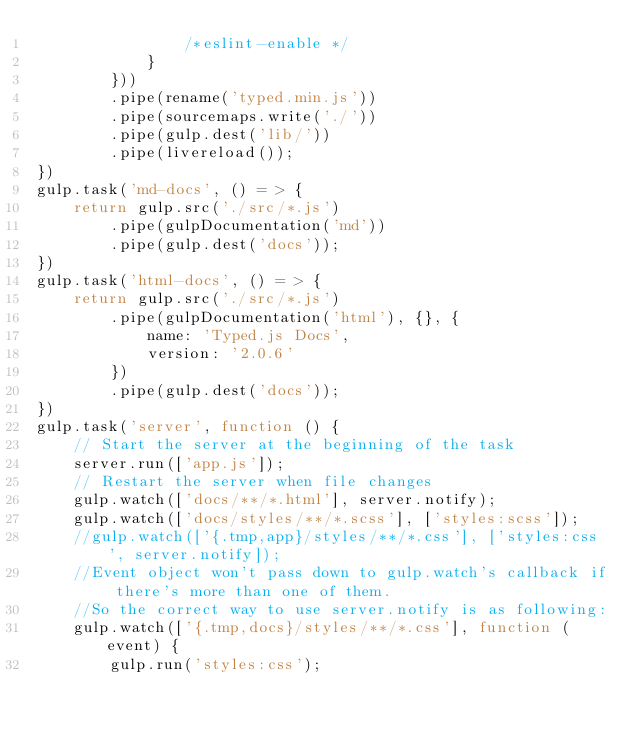Convert code to text. <code><loc_0><loc_0><loc_500><loc_500><_JavaScript_>                /*eslint-enable */
            }
        }))
        .pipe(rename('typed.min.js'))
        .pipe(sourcemaps.write('./'))
        .pipe(gulp.dest('lib/'))
        .pipe(livereload());
})
gulp.task('md-docs', () = > {
    return gulp.src('./src/*.js')
        .pipe(gulpDocumentation('md'))
        .pipe(gulp.dest('docs'));
})
gulp.task('html-docs', () = > {
    return gulp.src('./src/*.js')
        .pipe(gulpDocumentation('html'), {}, {
            name: 'Typed.js Docs',
            version: '2.0.6'
        })
        .pipe(gulp.dest('docs'));
})
gulp.task('server', function () {
    // Start the server at the beginning of the task
    server.run(['app.js']);
    // Restart the server when file changes
    gulp.watch(['docs/**/*.html'], server.notify);
    gulp.watch(['docs/styles/**/*.scss'], ['styles:scss']);
    //gulp.watch(['{.tmp,app}/styles/**/*.css'], ['styles:css', server.notify]);
    //Event object won't pass down to gulp.watch's callback if there's more than one of them.
    //So the correct way to use server.notify is as following:
    gulp.watch(['{.tmp,docs}/styles/**/*.css'], function (event) {
        gulp.run('styles:css');</code> 